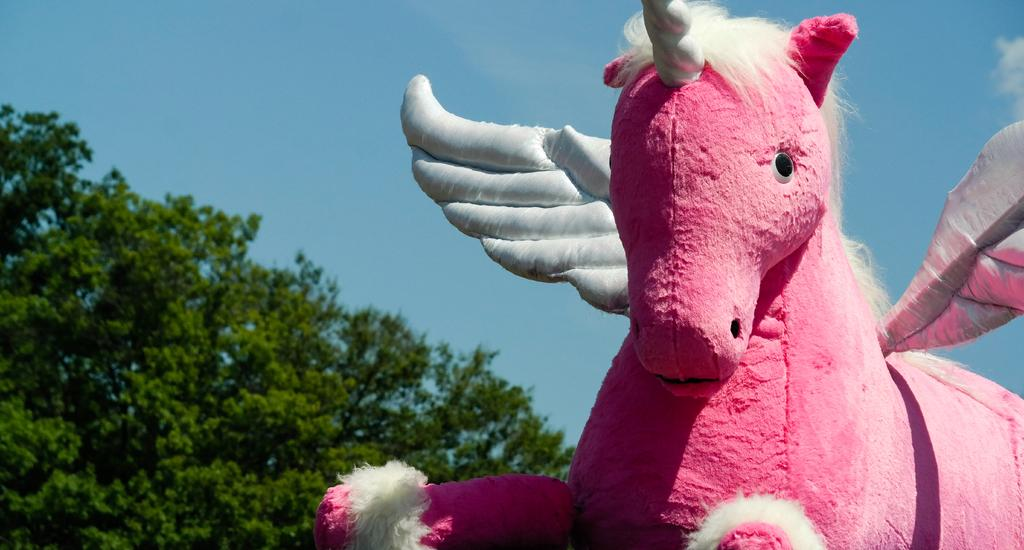What is the main subject of the image? There is a pink color unicorn statue in the image. What can be seen in the background of the image? Trees are visible in the background of the image. What is the color of the sky in the image? The sky is blue in color. How many gloves can be seen on the unicorn's hooves in the image? There are no gloves present in the image; it features a pink unicorn statue with no gloves on its hooves. Can you tell me how the unicorn is using the faucet in the image? There is no faucet present in the image; it only features a pink unicorn statue and trees in the background. 